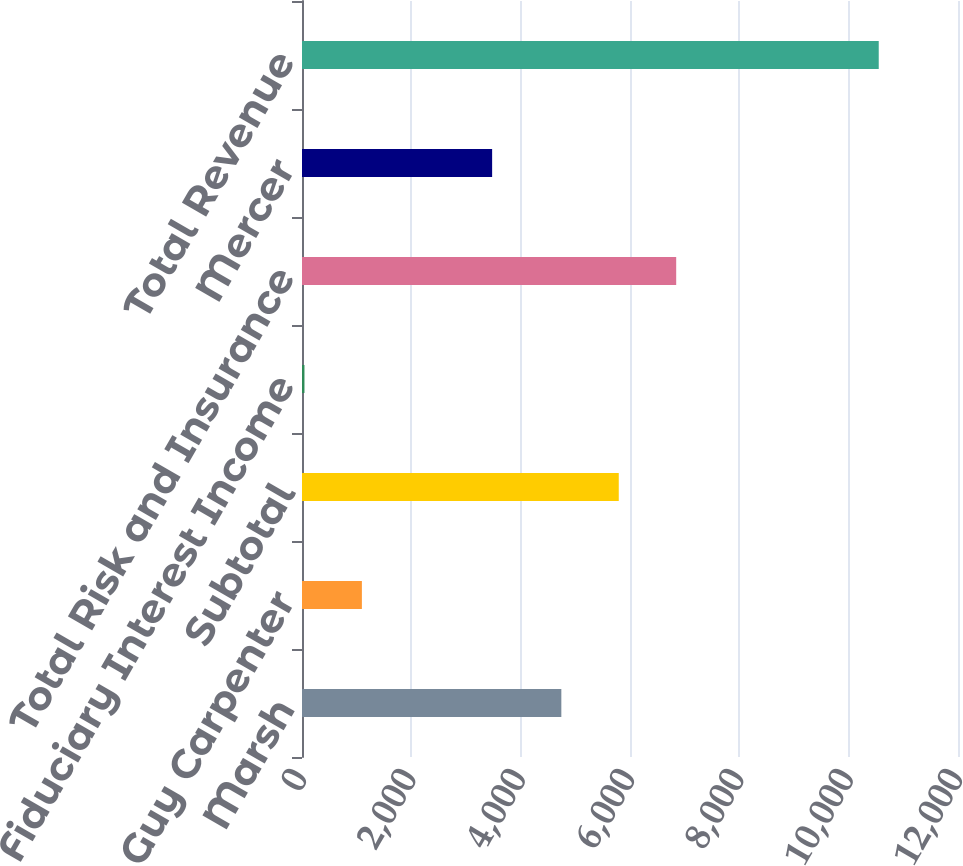Convert chart. <chart><loc_0><loc_0><loc_500><loc_500><bar_chart><fcel>Marsh<fcel>Guy Carpenter<fcel>Subtotal<fcel>Fiduciary Interest Income<fcel>Total Risk and Insurance<fcel>Mercer<fcel>Total Revenue<nl><fcel>4744<fcel>1095.5<fcel>5794.5<fcel>45<fcel>6845<fcel>3478<fcel>10550<nl></chart> 